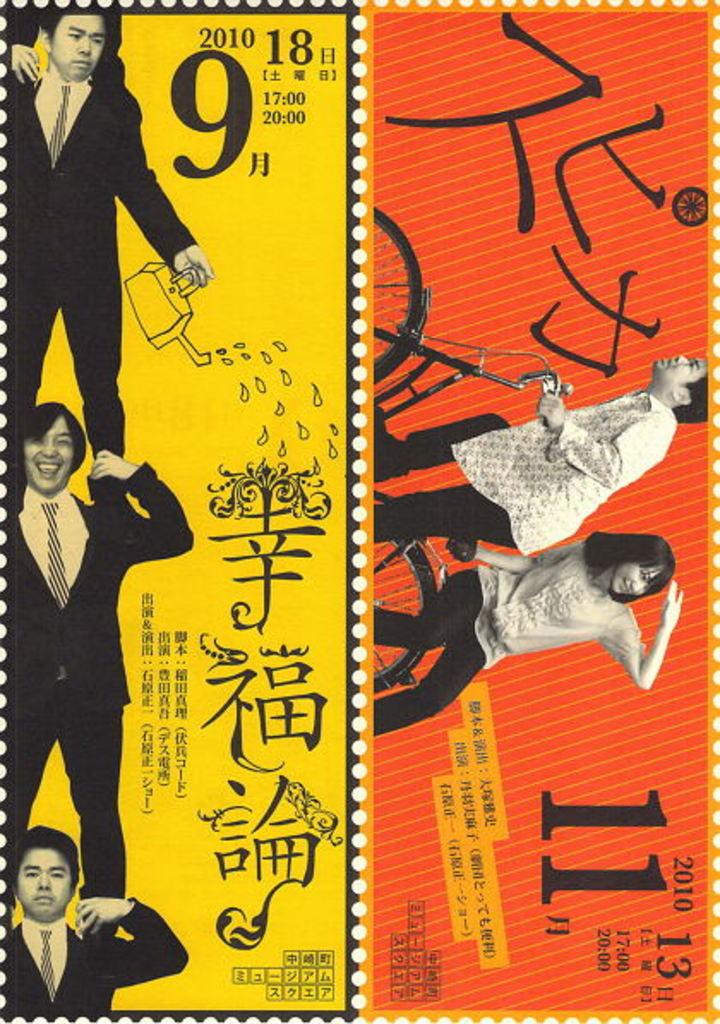What is the year shown?
Offer a very short reply. 2010. 